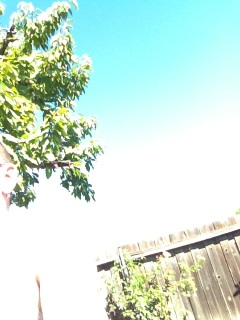Can you tell me more about the type of tree shown in this image? While I cannot determine the exact species without closer detail, the tree depicted in the image has broad, green leaves which might indicate it is a deciduous tree commonly found in temperate climates. 